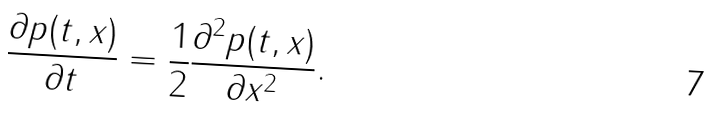<formula> <loc_0><loc_0><loc_500><loc_500>\frac { \partial p ( t , x ) } { \partial t } = \frac { 1 } { 2 } \frac { \partial ^ { 2 } p ( t , x ) } { \partial x ^ { 2 } } .</formula> 